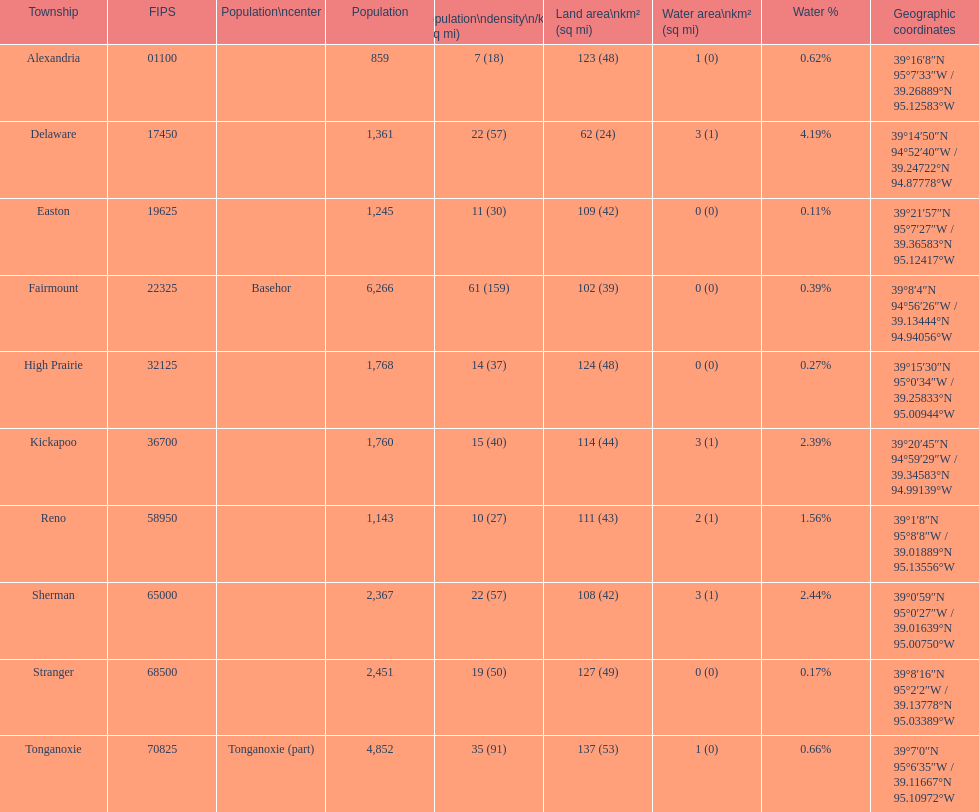Was delaware's land area above or below 45 square miles? Above. 